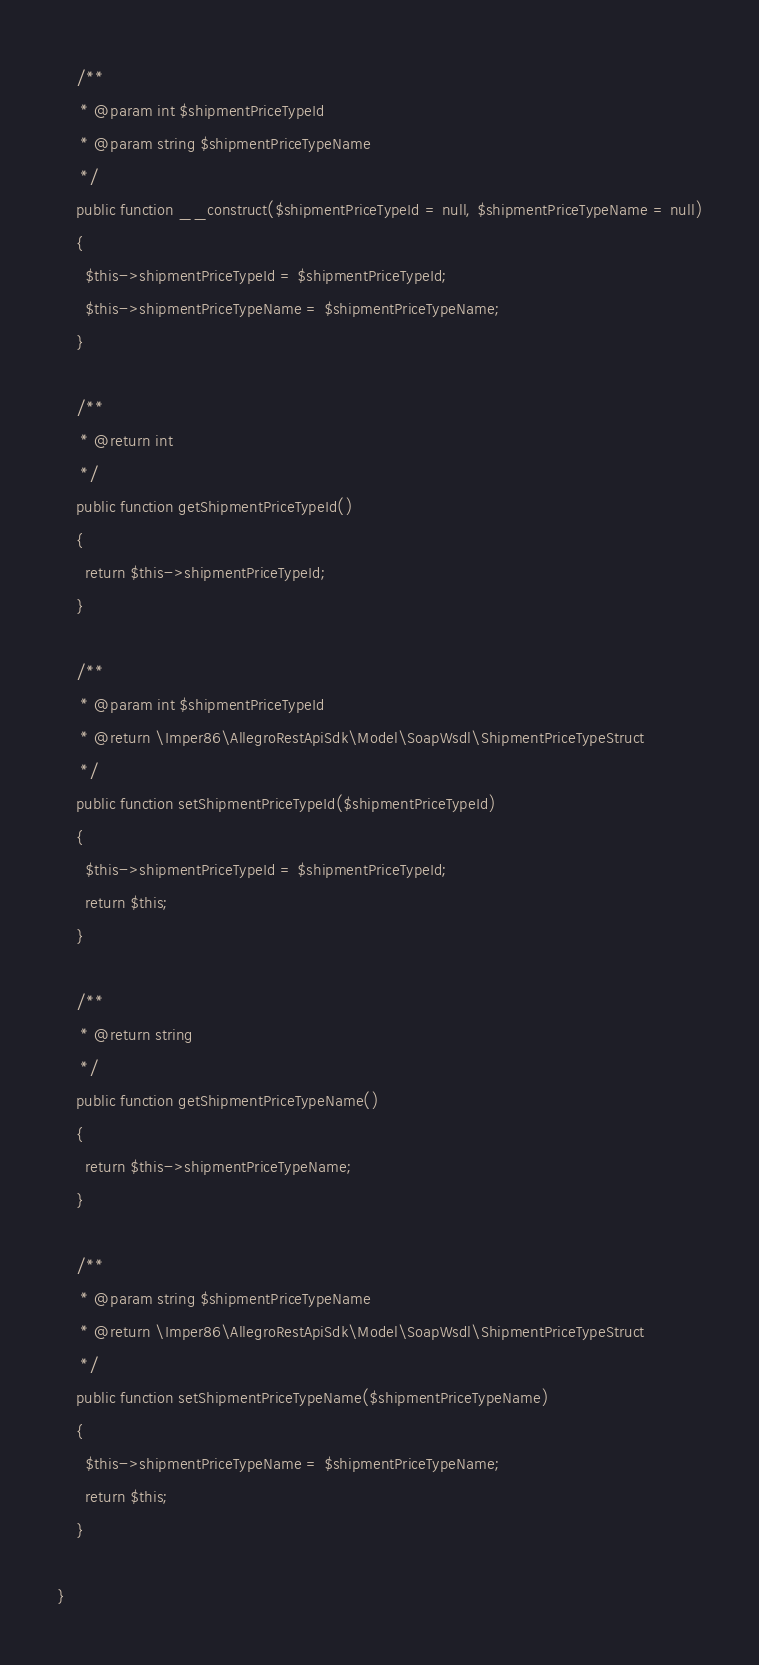<code> <loc_0><loc_0><loc_500><loc_500><_PHP_>    /**
     * @param int $shipmentPriceTypeId
     * @param string $shipmentPriceTypeName
     */
    public function __construct($shipmentPriceTypeId = null, $shipmentPriceTypeName = null)
    {
      $this->shipmentPriceTypeId = $shipmentPriceTypeId;
      $this->shipmentPriceTypeName = $shipmentPriceTypeName;
    }

    /**
     * @return int
     */
    public function getShipmentPriceTypeId()
    {
      return $this->shipmentPriceTypeId;
    }

    /**
     * @param int $shipmentPriceTypeId
     * @return \Imper86\AllegroRestApiSdk\Model\SoapWsdl\ShipmentPriceTypeStruct
     */
    public function setShipmentPriceTypeId($shipmentPriceTypeId)
    {
      $this->shipmentPriceTypeId = $shipmentPriceTypeId;
      return $this;
    }

    /**
     * @return string
     */
    public function getShipmentPriceTypeName()
    {
      return $this->shipmentPriceTypeName;
    }

    /**
     * @param string $shipmentPriceTypeName
     * @return \Imper86\AllegroRestApiSdk\Model\SoapWsdl\ShipmentPriceTypeStruct
     */
    public function setShipmentPriceTypeName($shipmentPriceTypeName)
    {
      $this->shipmentPriceTypeName = $shipmentPriceTypeName;
      return $this;
    }

}
</code> 